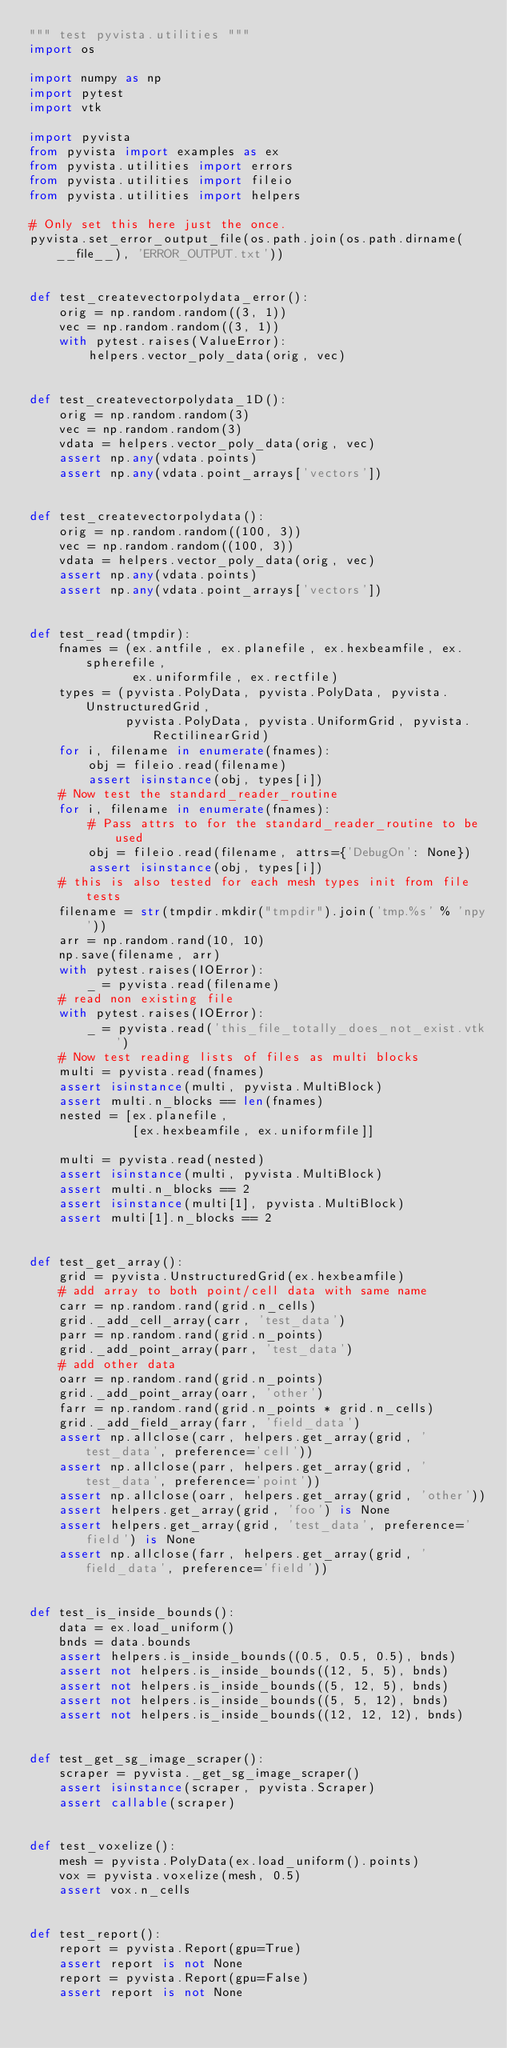Convert code to text. <code><loc_0><loc_0><loc_500><loc_500><_Python_>""" test pyvista.utilities """
import os

import numpy as np
import pytest
import vtk

import pyvista
from pyvista import examples as ex
from pyvista.utilities import errors
from pyvista.utilities import fileio
from pyvista.utilities import helpers

# Only set this here just the once.
pyvista.set_error_output_file(os.path.join(os.path.dirname(__file__), 'ERROR_OUTPUT.txt'))


def test_createvectorpolydata_error():
    orig = np.random.random((3, 1))
    vec = np.random.random((3, 1))
    with pytest.raises(ValueError):
        helpers.vector_poly_data(orig, vec)


def test_createvectorpolydata_1D():
    orig = np.random.random(3)
    vec = np.random.random(3)
    vdata = helpers.vector_poly_data(orig, vec)
    assert np.any(vdata.points)
    assert np.any(vdata.point_arrays['vectors'])


def test_createvectorpolydata():
    orig = np.random.random((100, 3))
    vec = np.random.random((100, 3))
    vdata = helpers.vector_poly_data(orig, vec)
    assert np.any(vdata.points)
    assert np.any(vdata.point_arrays['vectors'])


def test_read(tmpdir):
    fnames = (ex.antfile, ex.planefile, ex.hexbeamfile, ex.spherefile,
              ex.uniformfile, ex.rectfile)
    types = (pyvista.PolyData, pyvista.PolyData, pyvista.UnstructuredGrid,
             pyvista.PolyData, pyvista.UniformGrid, pyvista.RectilinearGrid)
    for i, filename in enumerate(fnames):
        obj = fileio.read(filename)
        assert isinstance(obj, types[i])
    # Now test the standard_reader_routine
    for i, filename in enumerate(fnames):
        # Pass attrs to for the standard_reader_routine to be used
        obj = fileio.read(filename, attrs={'DebugOn': None})
        assert isinstance(obj, types[i])
    # this is also tested for each mesh types init from file tests
    filename = str(tmpdir.mkdir("tmpdir").join('tmp.%s' % 'npy'))
    arr = np.random.rand(10, 10)
    np.save(filename, arr)
    with pytest.raises(IOError):
        _ = pyvista.read(filename)
    # read non existing file
    with pytest.raises(IOError):
        _ = pyvista.read('this_file_totally_does_not_exist.vtk')
    # Now test reading lists of files as multi blocks
    multi = pyvista.read(fnames)
    assert isinstance(multi, pyvista.MultiBlock)
    assert multi.n_blocks == len(fnames)
    nested = [ex.planefile,
              [ex.hexbeamfile, ex.uniformfile]]

    multi = pyvista.read(nested)
    assert isinstance(multi, pyvista.MultiBlock)
    assert multi.n_blocks == 2
    assert isinstance(multi[1], pyvista.MultiBlock)
    assert multi[1].n_blocks == 2


def test_get_array():
    grid = pyvista.UnstructuredGrid(ex.hexbeamfile)
    # add array to both point/cell data with same name
    carr = np.random.rand(grid.n_cells)
    grid._add_cell_array(carr, 'test_data')
    parr = np.random.rand(grid.n_points)
    grid._add_point_array(parr, 'test_data')
    # add other data
    oarr = np.random.rand(grid.n_points)
    grid._add_point_array(oarr, 'other')
    farr = np.random.rand(grid.n_points * grid.n_cells)
    grid._add_field_array(farr, 'field_data')
    assert np.allclose(carr, helpers.get_array(grid, 'test_data', preference='cell'))
    assert np.allclose(parr, helpers.get_array(grid, 'test_data', preference='point'))
    assert np.allclose(oarr, helpers.get_array(grid, 'other'))
    assert helpers.get_array(grid, 'foo') is None
    assert helpers.get_array(grid, 'test_data', preference='field') is None
    assert np.allclose(farr, helpers.get_array(grid, 'field_data', preference='field'))


def test_is_inside_bounds():
    data = ex.load_uniform()
    bnds = data.bounds
    assert helpers.is_inside_bounds((0.5, 0.5, 0.5), bnds)
    assert not helpers.is_inside_bounds((12, 5, 5), bnds)
    assert not helpers.is_inside_bounds((5, 12, 5), bnds)
    assert not helpers.is_inside_bounds((5, 5, 12), bnds)
    assert not helpers.is_inside_bounds((12, 12, 12), bnds)


def test_get_sg_image_scraper():
    scraper = pyvista._get_sg_image_scraper()
    assert isinstance(scraper, pyvista.Scraper)
    assert callable(scraper)


def test_voxelize():
    mesh = pyvista.PolyData(ex.load_uniform().points)
    vox = pyvista.voxelize(mesh, 0.5)
    assert vox.n_cells


def test_report():
    report = pyvista.Report(gpu=True)
    assert report is not None
    report = pyvista.Report(gpu=False)
    assert report is not None

</code> 